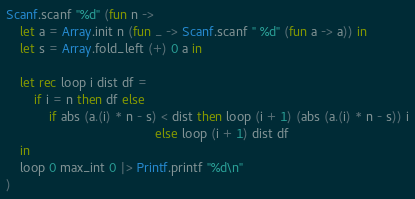Convert code to text. <code><loc_0><loc_0><loc_500><loc_500><_OCaml_>Scanf.scanf "%d" (fun n ->
    let a = Array.init n (fun _ -> Scanf.scanf " %d" (fun a -> a)) in
    let s = Array.fold_left (+) 0 a in

    let rec loop i dist df =
        if i = n then df else
            if abs (a.(i) * n - s) < dist then loop (i + 1) (abs (a.(i) * n - s)) i
                                          else loop (i + 1) dist df
    in
    loop 0 max_int 0 |> Printf.printf "%d\n"
)</code> 